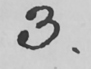What does this handwritten line say? 3 . 